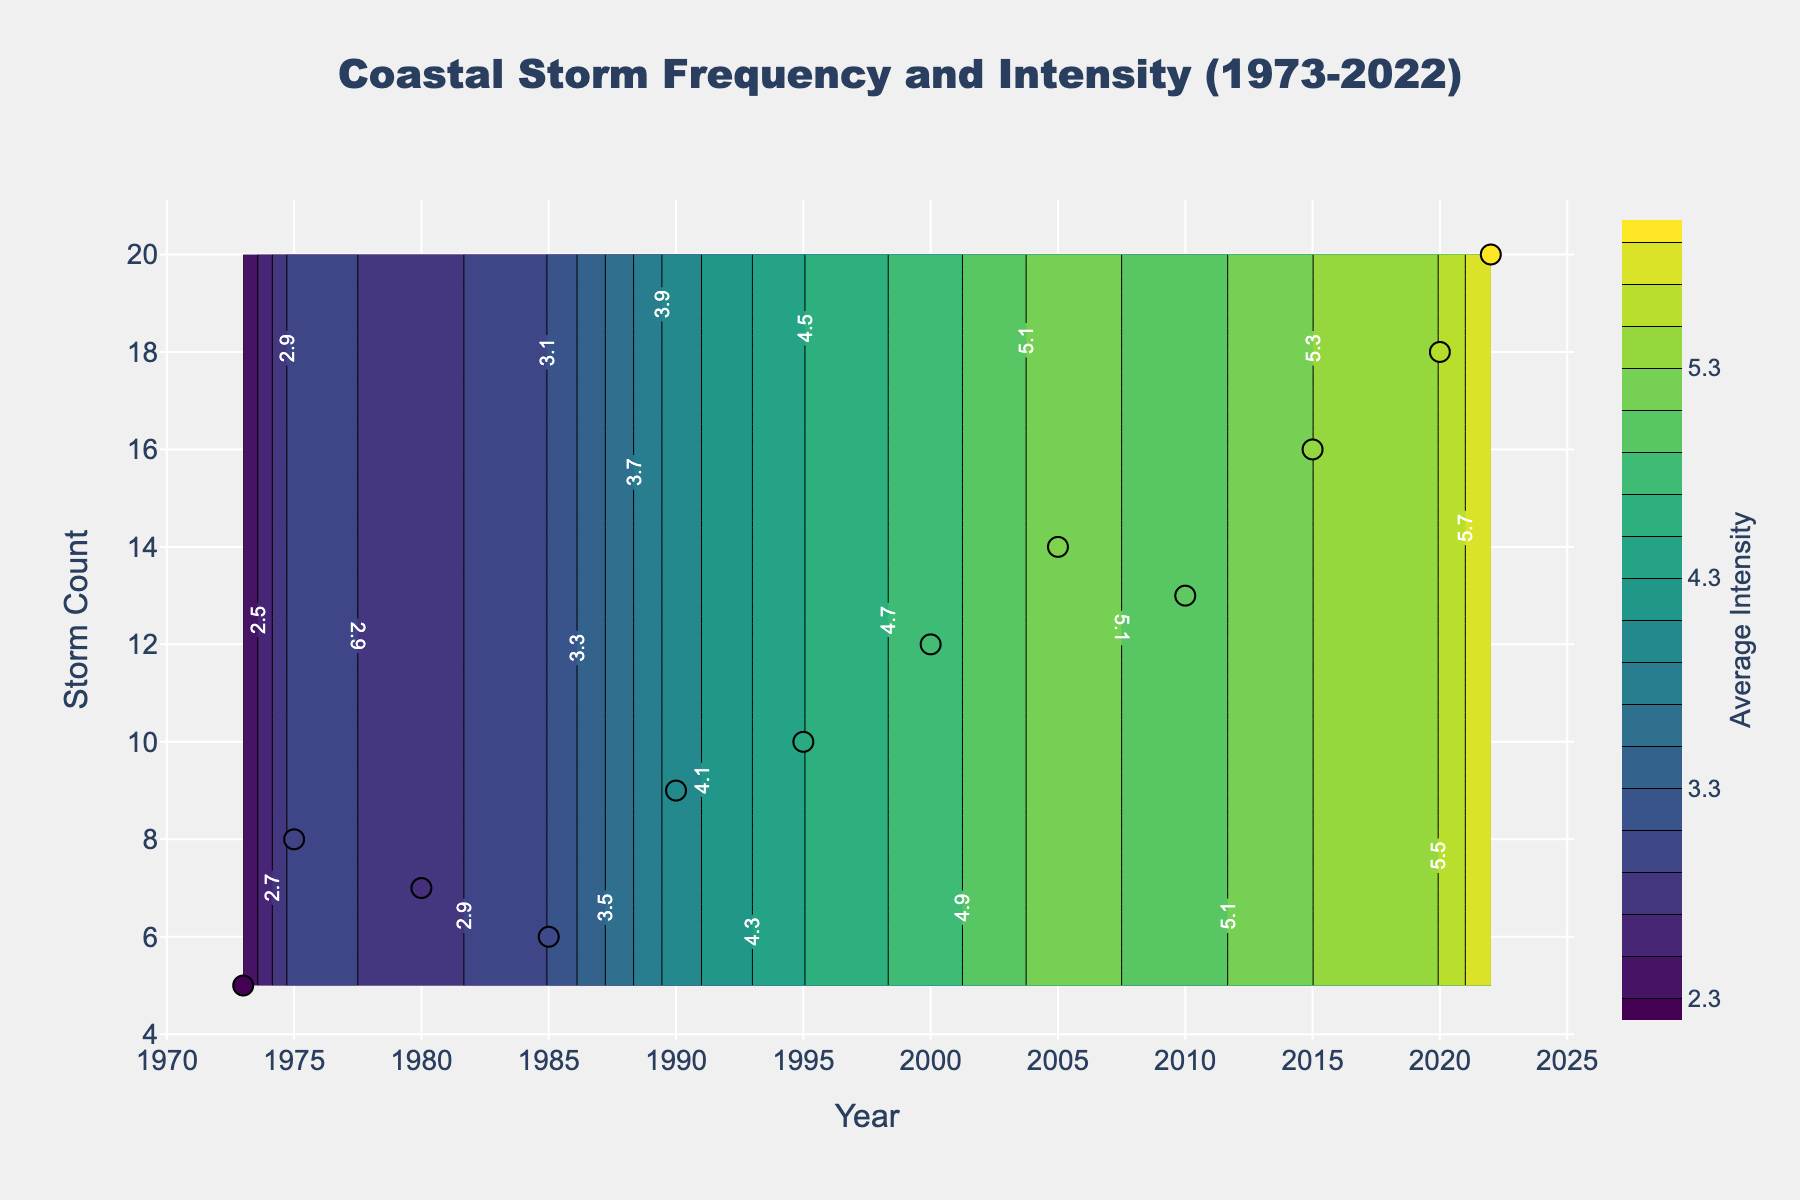What is the title of the plot? The title is usually placed at the top of the figure, often in larger and bolder text to draw attention. In this figure, the title "Coastal Storm Frequency and Intensity (1973-2022)" is located at the top center.
Answer: Coastal Storm Frequency and Intensity (1973-2022) What are the x-axis and y-axis labels? The axis labels are typically adjacent to the axes. In this figure, the x-axis is labeled "Year" and the y-axis is labeled "Storm Count."
Answer: Year and Storm Count How many data points are represented as markers on the plot? Markers are displayed as individual points on the plot. By counting them, we notice there are 12 markers, each representing a different year from 1973 to 2022.
Answer: 12 What is the storm count in the year 2020? By locating the year 2020 on the x-axis and finding its corresponding marker, we see it aligns with a storm count of 18 on the y-axis.
Answer: 18 How has the average intensity of coastal storms changed from 1973 to 2022? To determine the change, compare the average intensities at the start and end years. In 1973, the intensity was 2.3, and in 2022, it was 5.9, indicating an increase.
Answer: Increased Which year recorded the highest average storm intensity and what was it? By looking at the markers and color gradients, the year 2022 has the darkest color, showing the highest intensity. By hovering over or reading the scale, we find it was 5.9.
Answer: 2022, 5.9 During which decade did we observe the largest increase in storm count? To find this, compare storm counts between decades: 1970s-1980s, 1980s-1990s, etc. The biggest increase was seen from 2000 (12 storms) to 2010 (13 storms) before peaking significantly from 2010 to 2020 (18 storms).
Answer: 2010-2020 What is the rate of increase in the number of storms from 1973 to 2022? First, find the difference in storm count from 2022 (20) and 1973 (5), which is 15. Then, divide by the number of years (2022-1973 = 49 years), resulting in 15/49 ≈ 0.31 storms per year.
Answer: 0.31 storms per year How does the average storm intensity in 2015 compare to that in 1985? Comparing the markers for these years, in 1985 the intensity was 3.1, and in 2015 it was 5.3. Thus, intensity in 2015 is higher by 2.2 units.
Answer: 2.2 units higher 